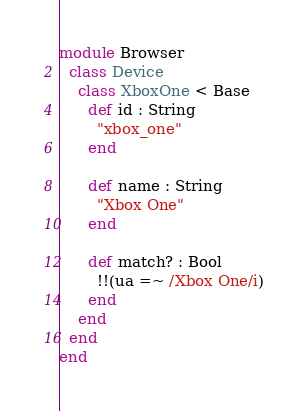<code> <loc_0><loc_0><loc_500><loc_500><_Crystal_>module Browser
  class Device
    class XboxOne < Base
      def id : String
        "xbox_one"
      end

      def name : String
        "Xbox One"
      end

      def match? : Bool
        !!(ua =~ /Xbox One/i)
      end
    end
  end
end
</code> 